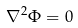<formula> <loc_0><loc_0><loc_500><loc_500>\nabla ^ { 2 } \Phi = 0</formula> 